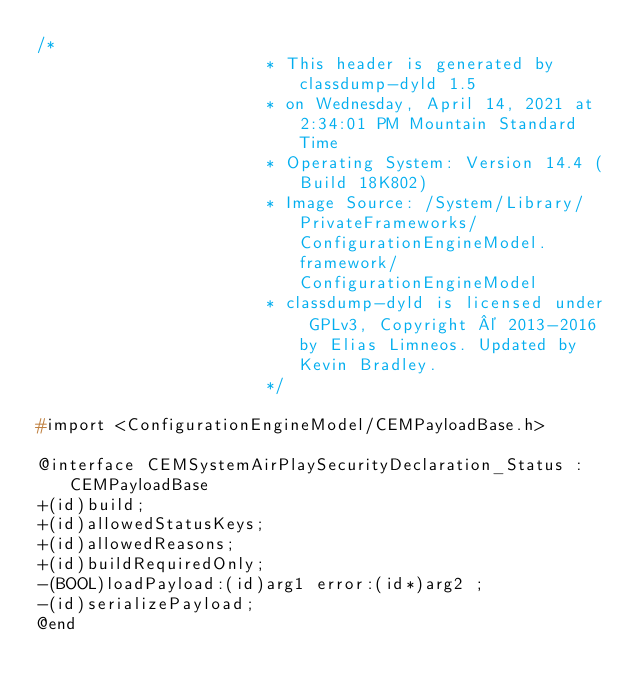<code> <loc_0><loc_0><loc_500><loc_500><_C_>/*
                       * This header is generated by classdump-dyld 1.5
                       * on Wednesday, April 14, 2021 at 2:34:01 PM Mountain Standard Time
                       * Operating System: Version 14.4 (Build 18K802)
                       * Image Source: /System/Library/PrivateFrameworks/ConfigurationEngineModel.framework/ConfigurationEngineModel
                       * classdump-dyld is licensed under GPLv3, Copyright © 2013-2016 by Elias Limneos. Updated by Kevin Bradley.
                       */

#import <ConfigurationEngineModel/CEMPayloadBase.h>

@interface CEMSystemAirPlaySecurityDeclaration_Status : CEMPayloadBase
+(id)build;
+(id)allowedStatusKeys;
+(id)allowedReasons;
+(id)buildRequiredOnly;
-(BOOL)loadPayload:(id)arg1 error:(id*)arg2 ;
-(id)serializePayload;
@end

</code> 